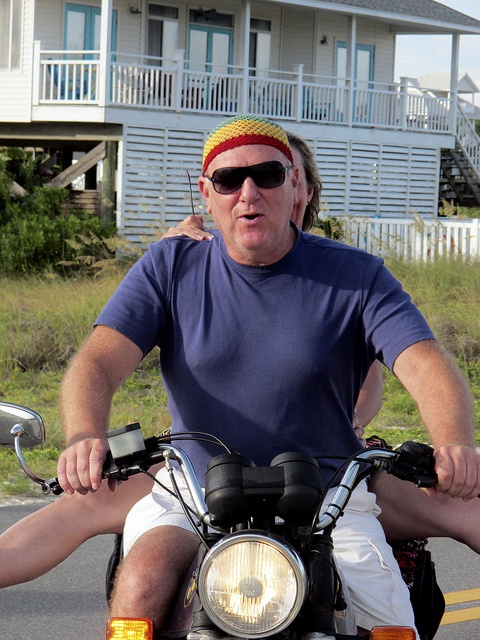Describe the objects in this image and their specific colors. I can see people in darkgray, black, purple, navy, and brown tones, motorcycle in darkgray, black, ivory, and gray tones, and people in darkgray, gray, brown, and black tones in this image. 